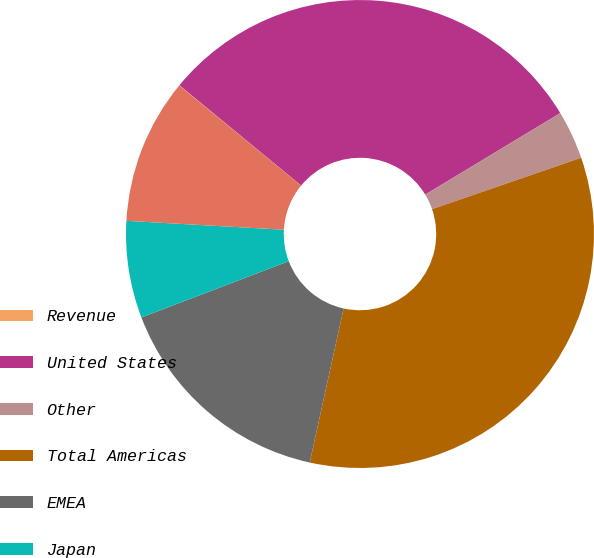<chart> <loc_0><loc_0><loc_500><loc_500><pie_chart><fcel>Revenue<fcel>United States<fcel>Other<fcel>Total Americas<fcel>EMEA<fcel>Japan<fcel>Total APAC<nl><fcel>0.02%<fcel>30.39%<fcel>3.36%<fcel>33.73%<fcel>15.75%<fcel>6.7%<fcel>10.05%<nl></chart> 